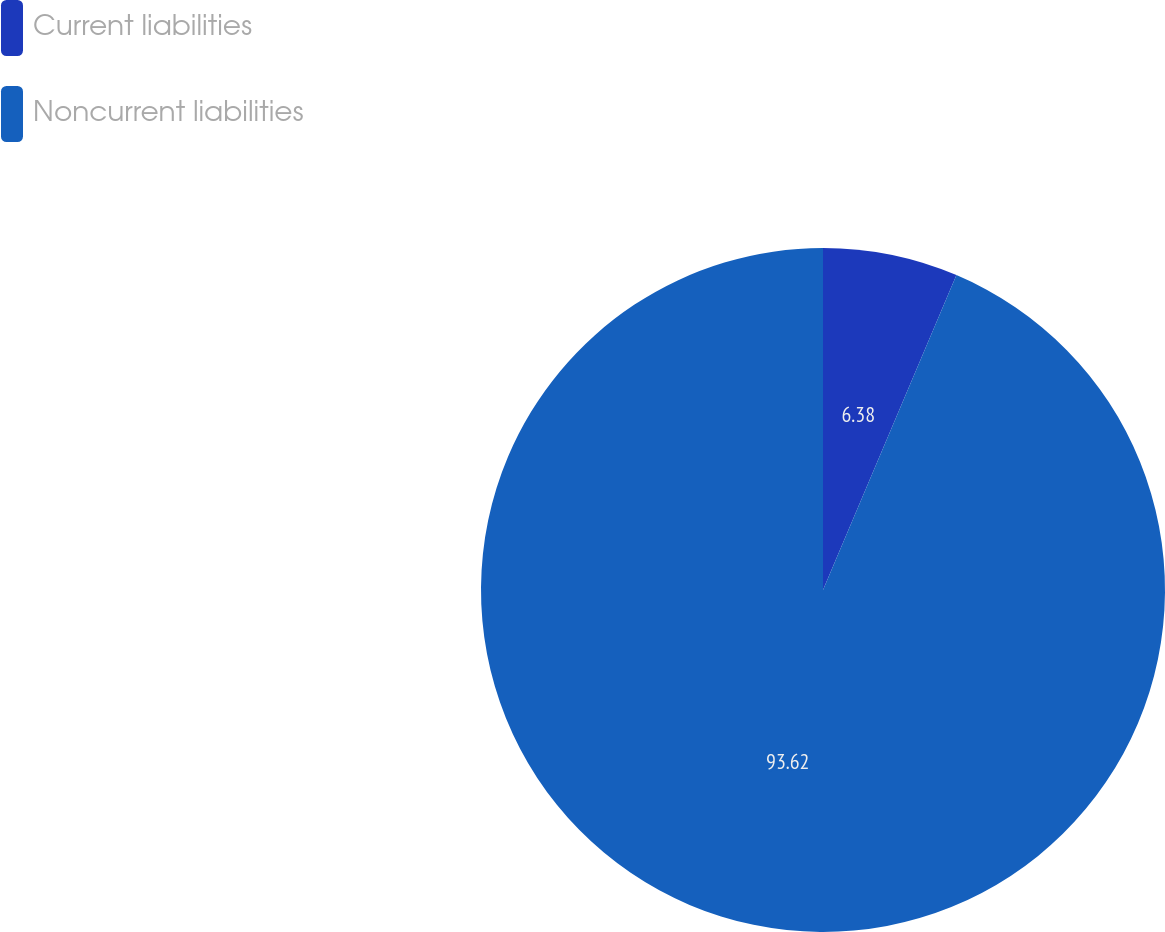Convert chart. <chart><loc_0><loc_0><loc_500><loc_500><pie_chart><fcel>Current liabilities<fcel>Noncurrent liabilities<nl><fcel>6.38%<fcel>93.62%<nl></chart> 